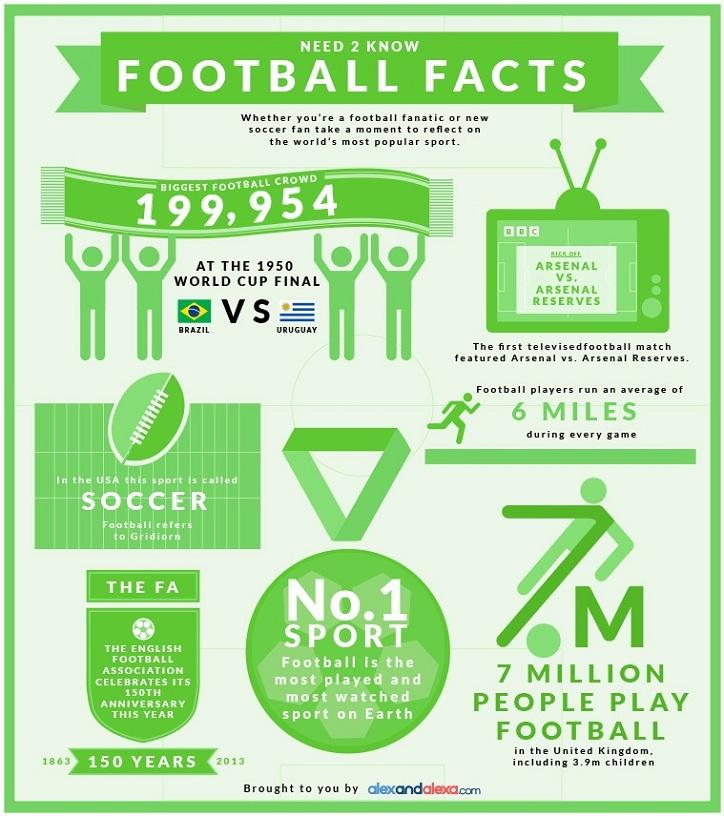Draw attention to some important aspects in this diagram. In the United Kingdom in 2013, it was estimated that approximately 3.9 million children played football. A football player ran a total of 6 miles during the game. The English Football Association was established in the United Kingdom in the year 1863. Brazil and Uruguay were the two teams that competed in the finals of the football World Cup in 1950. 